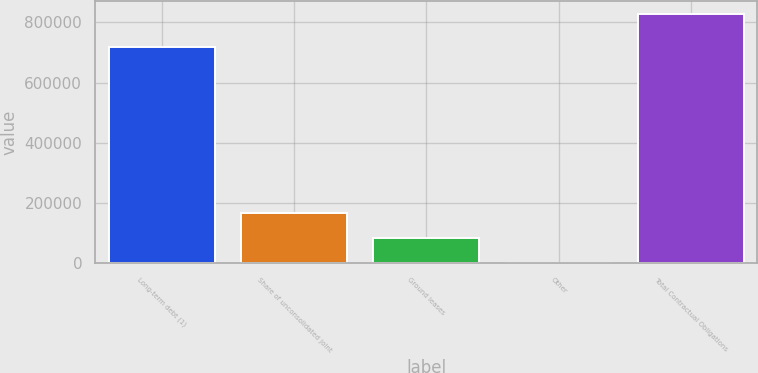<chart> <loc_0><loc_0><loc_500><loc_500><bar_chart><fcel>Long-term debt (1)<fcel>Share of unconsolidated joint<fcel>Ground leases<fcel>Other<fcel>Total Contractual Obligations<nl><fcel>717136<fcel>168000<fcel>85457.9<fcel>2916<fcel>828335<nl></chart> 